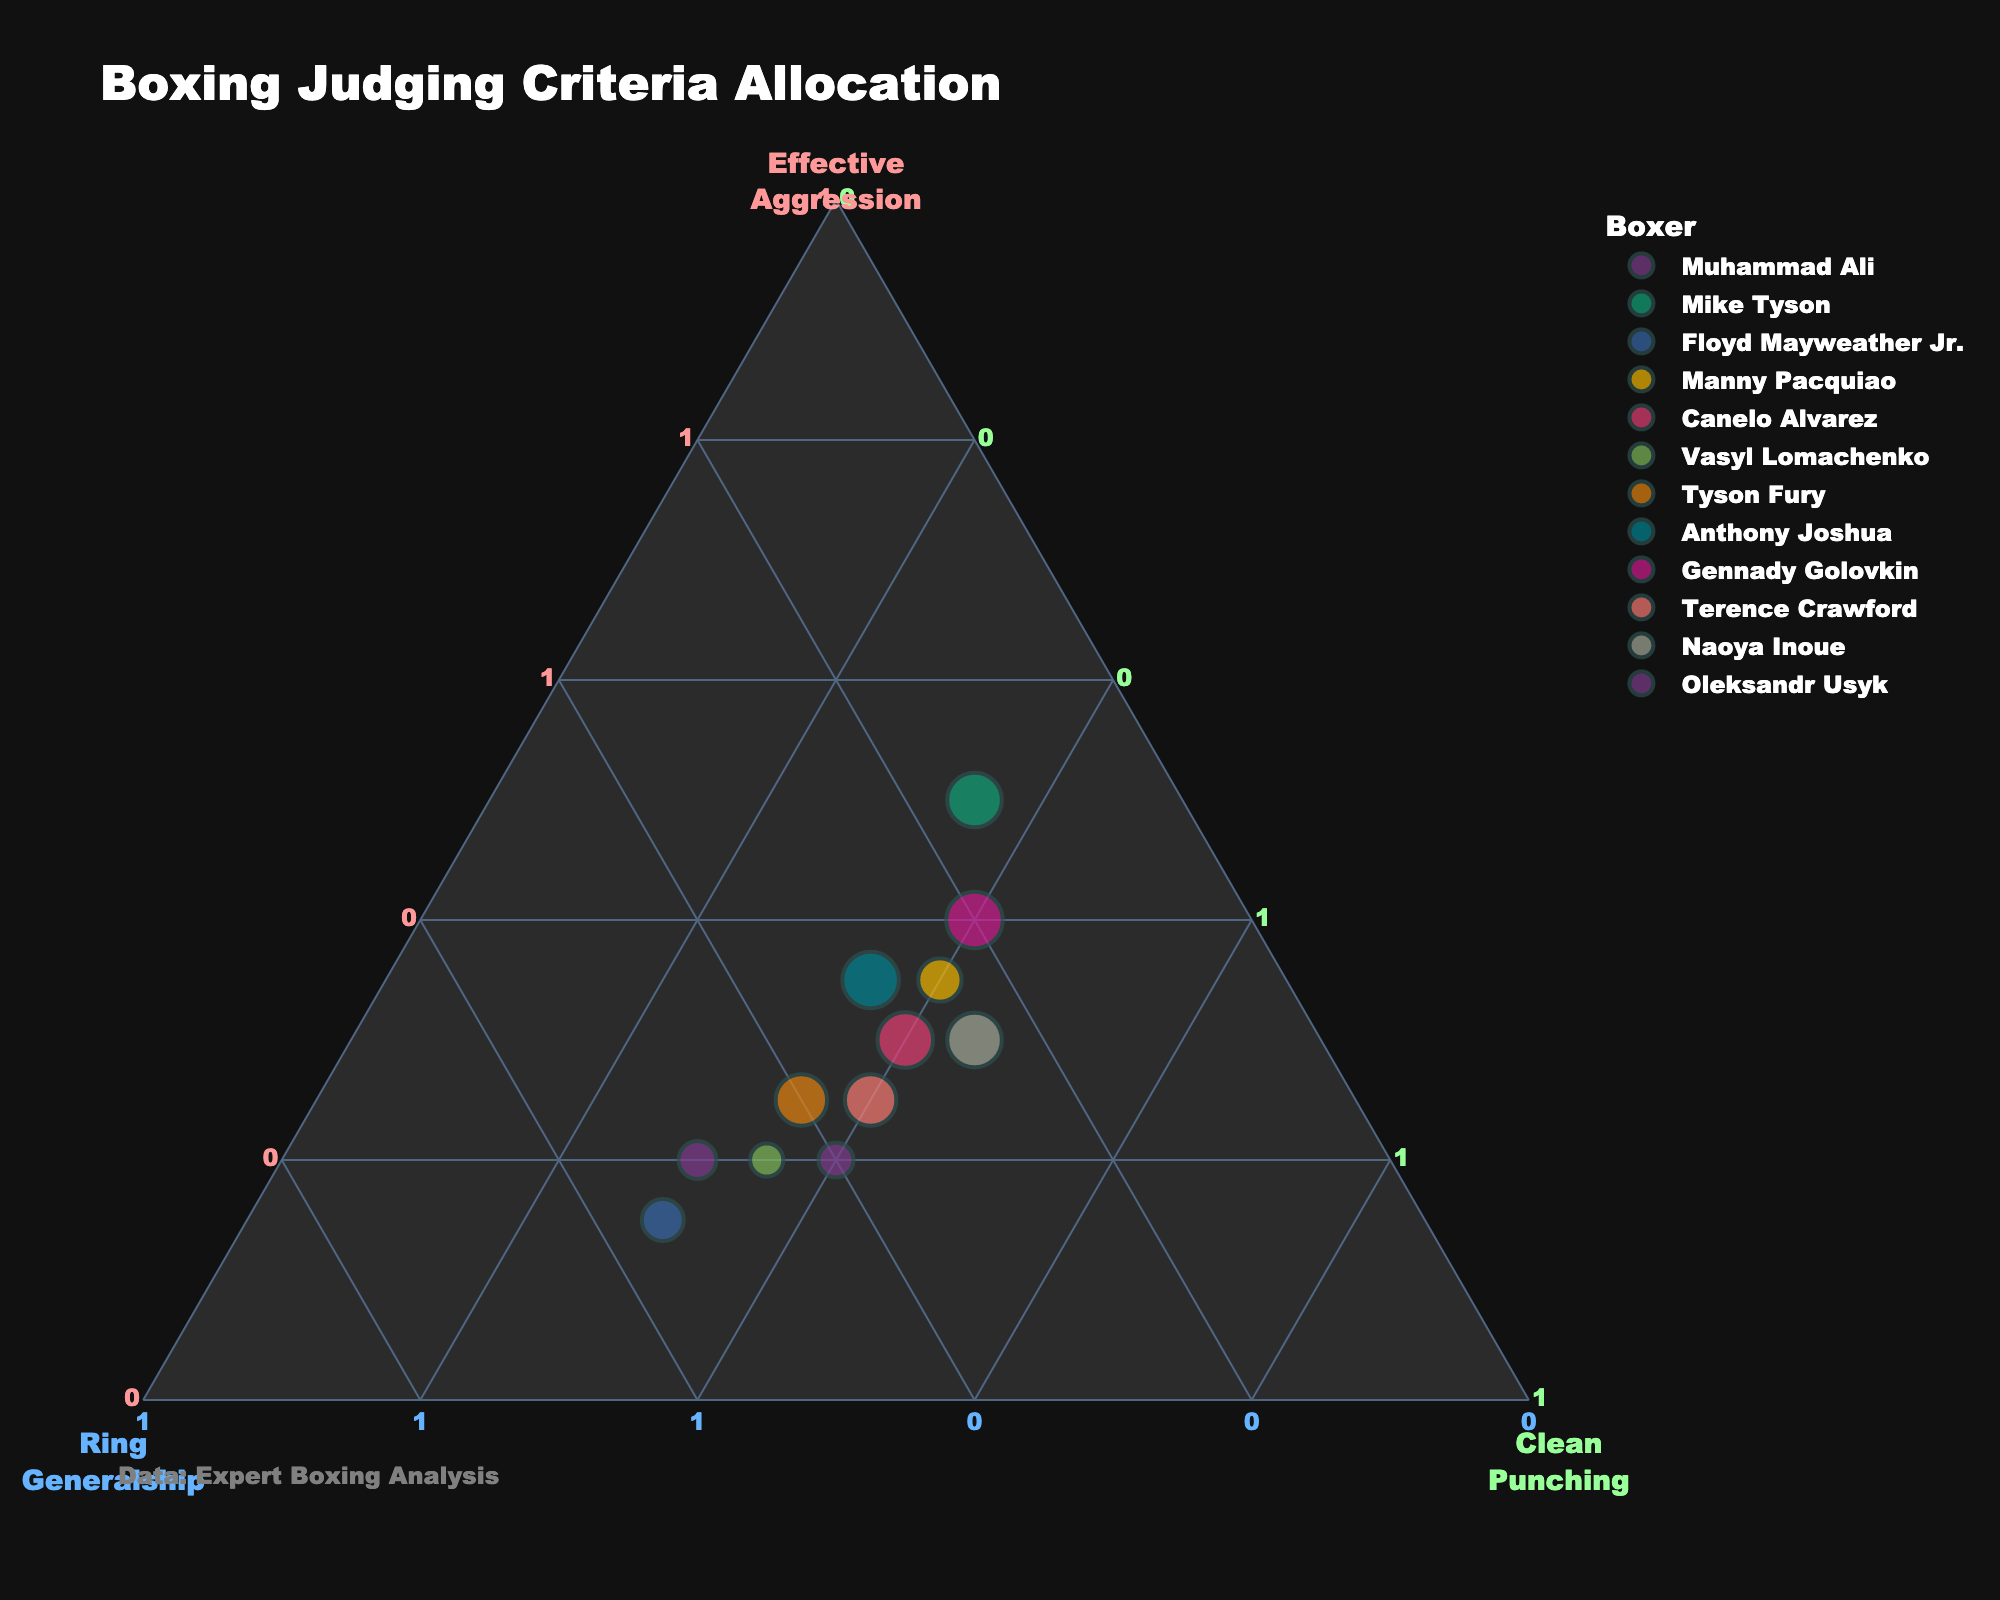How many boxers are represented in the plot? By counting the number of unique data points labeled by boxers' names, you determine the total number of boxers.
Answer: 12 Which boxer has the highest allocation for Effective Aggression? From the ternary plot, identify the point that is closest to the Effective Aggression axis and check the name it is labelled with.
Answer: Mike Tyson What are the three criteria used in the plot? The plot title and axis labels indicate the three criteria being evaluated: Effective Aggression, Ring Generalship, and Clean Punching.
Answer: Effective Aggression, Ring Generalship, Clean Punching Which boxer has an equal allocation in all three criteria? Scan the plot for a data point near the center where Effective Aggression, Ring Generalship, and Clean Punching values are closer to being equal.
Answer: Canelo Alvarez What is the average allocation for Clean Punching across all boxers? Sum the Clean Punching values for all boxers (30+35+30+40+40+35+35+35+40+40+45+40=445), then divide by the number of boxers (12).
Answer: 37.08 Do Floyd Mayweather Jr. and Manny Pacquiao have any criteria allocation equal in value? Check whether any of the three criteria for Floyd Mayweather Jr. and Manny Pacquiao have the same percentage value.
Answer: Yes, Clean Punching (30%) Which boxer has the lowest allocation for Ring Generalship? Identify the data point nearest to the Clean Punching and Effective Aggression axes, which corresponds to the lowest Ring Generalship value.
Answer: Mike Tyson What is the combined allocation for Effective Aggression and Clean Punching for Gennady Golovkin? Add the Effective Aggression (40) and Clean Punching (40) values for Gennady Golovkin: 40 + 40 = 80.
Answer: 80 Which criterion does Vasyl Lomachenko prioritize the most according to the plot? Locate Vasyl Lomachenko on the plot, then determine which axis the point is closest to, indicating the highest value.
Answer: Ring Generalship 